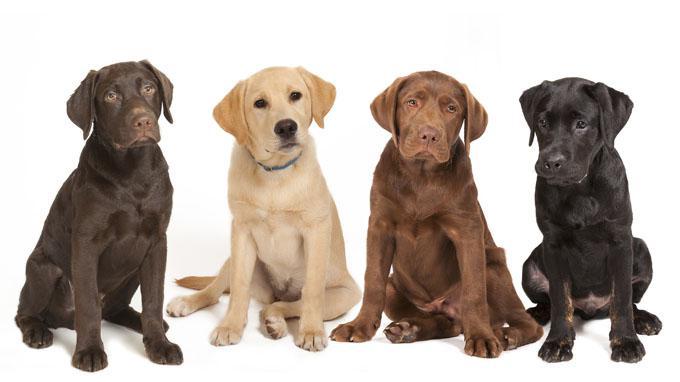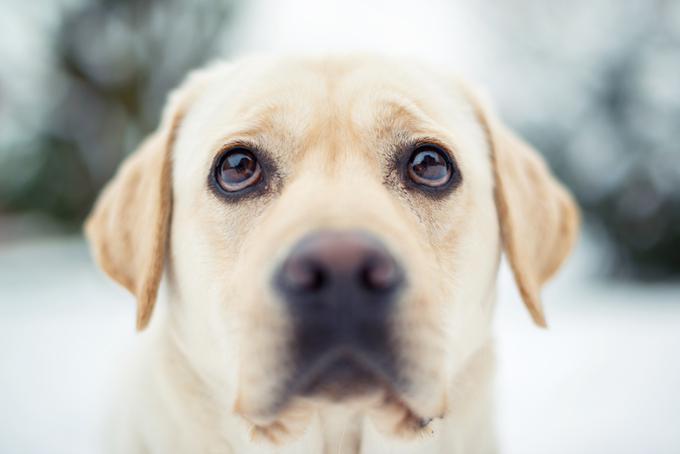The first image is the image on the left, the second image is the image on the right. Given the left and right images, does the statement "There are no more than four labrador retrievers" hold true? Answer yes or no. No. 